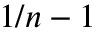Convert formula to latex. <formula><loc_0><loc_0><loc_500><loc_500>1 / n - 1</formula> 